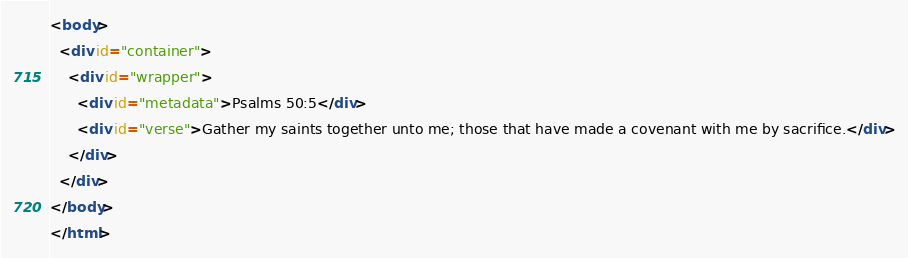Convert code to text. <code><loc_0><loc_0><loc_500><loc_500><_HTML_><body>
  <div id="container">
    <div id="wrapper">
      <div id="metadata">Psalms 50:5</div>
      <div id="verse">Gather my saints together unto me; those that have made a covenant with me by sacrifice.</div>
    </div>
  </div>
</body>
</html></code> 